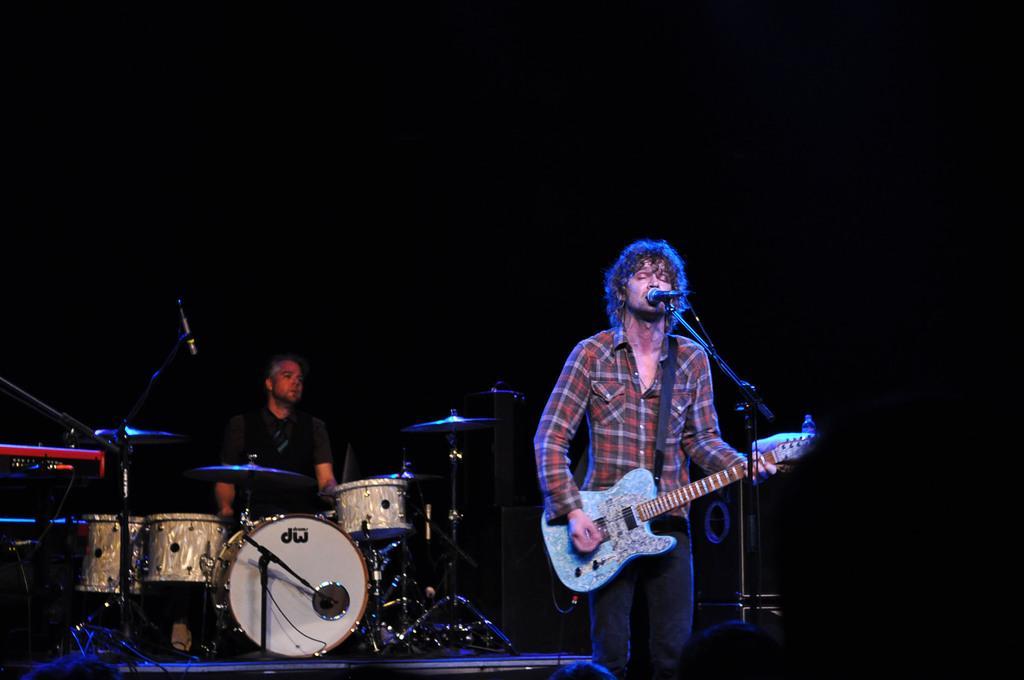Describe this image in one or two sentences. A man is standing and playing guitar in front of the mike which is on a stand and on the left we can see a person is playing drums. In the background the image is dark. At the bottom on the left side there are musical instruments. 